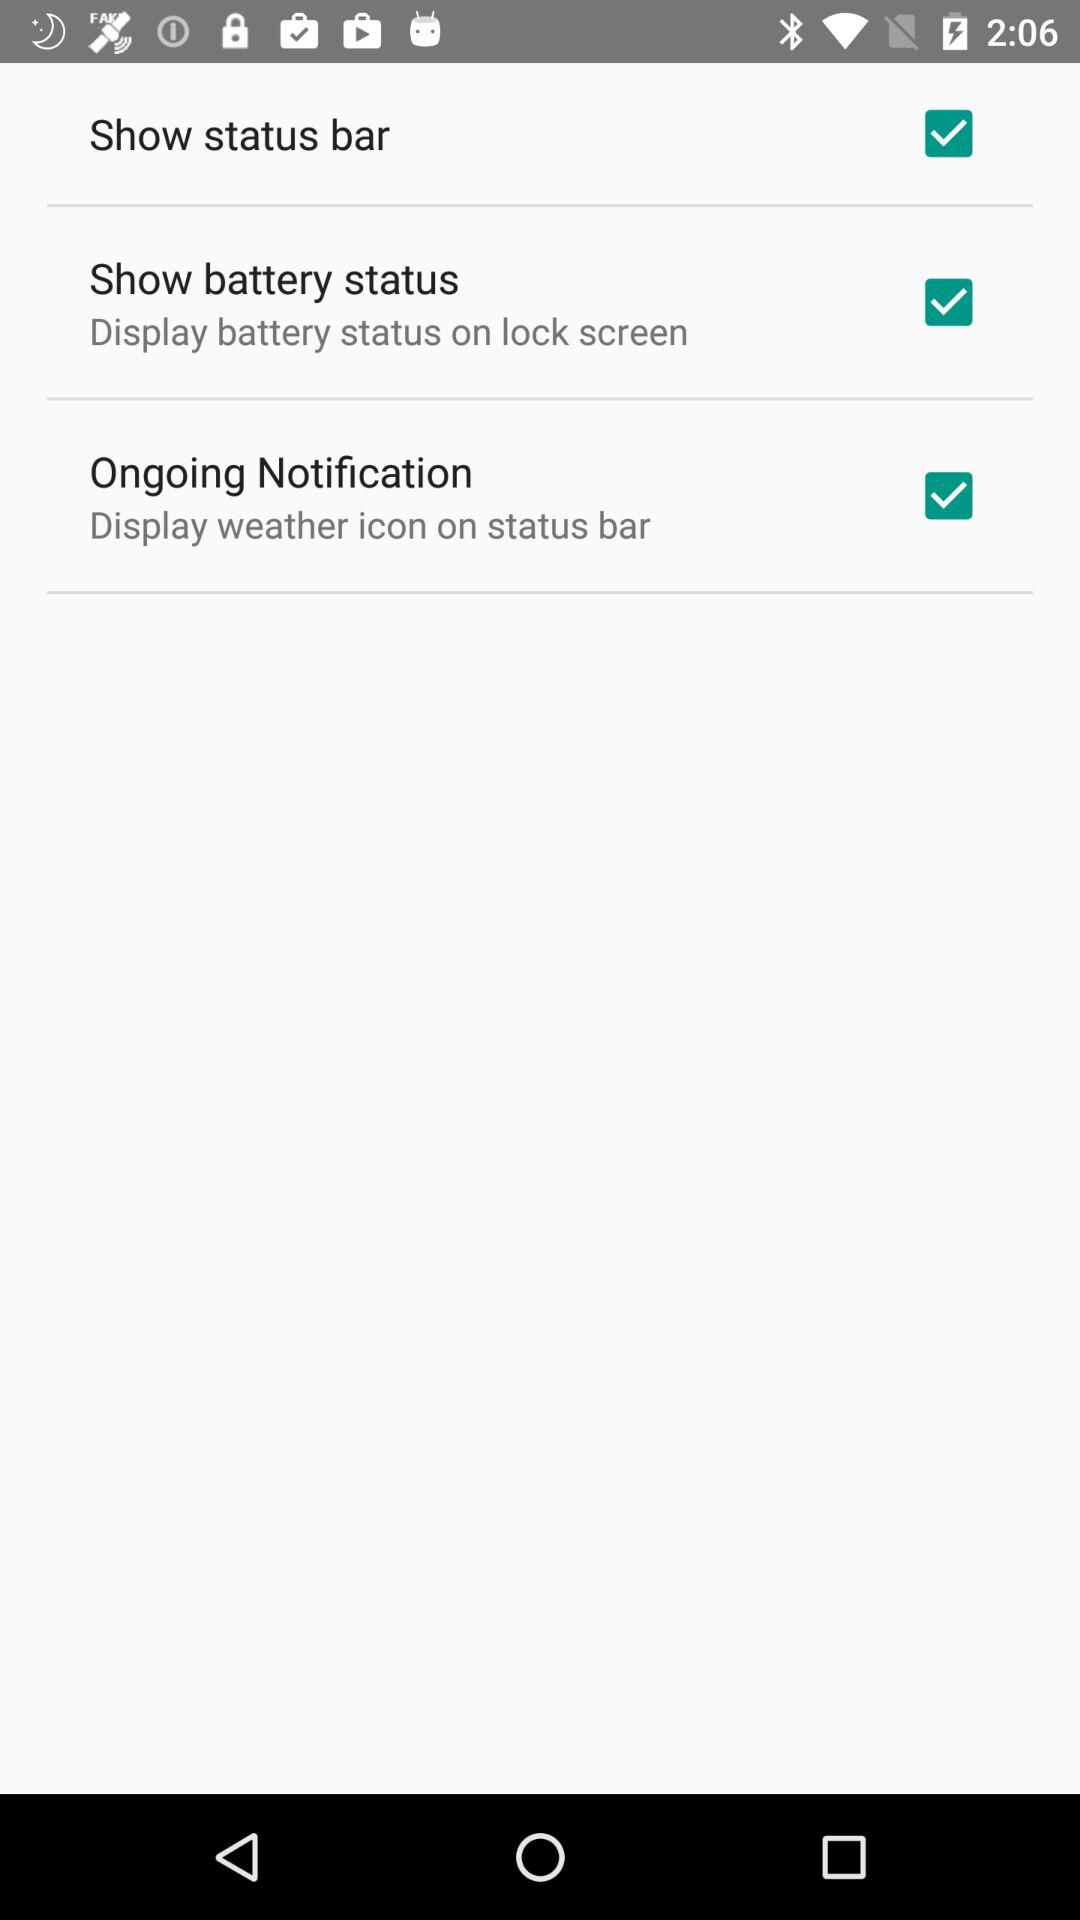How many settings are available to customize the status bar?
Answer the question using a single word or phrase. 3 